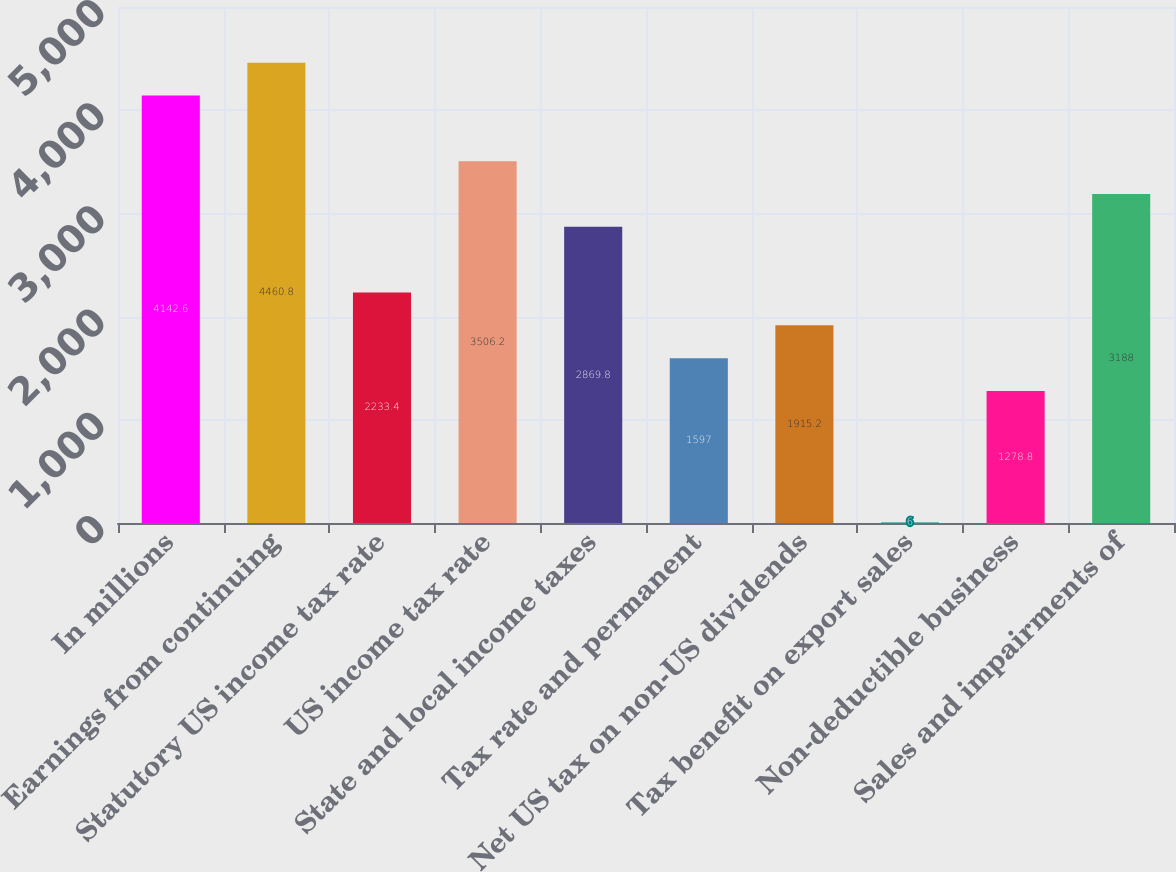Convert chart. <chart><loc_0><loc_0><loc_500><loc_500><bar_chart><fcel>In millions<fcel>Earnings from continuing<fcel>Statutory US income tax rate<fcel>US income tax rate<fcel>State and local income taxes<fcel>Tax rate and permanent<fcel>Net US tax on non-US dividends<fcel>Tax benefit on export sales<fcel>Non-deductible business<fcel>Sales and impairments of<nl><fcel>4142.6<fcel>4460.8<fcel>2233.4<fcel>3506.2<fcel>2869.8<fcel>1597<fcel>1915.2<fcel>6<fcel>1278.8<fcel>3188<nl></chart> 